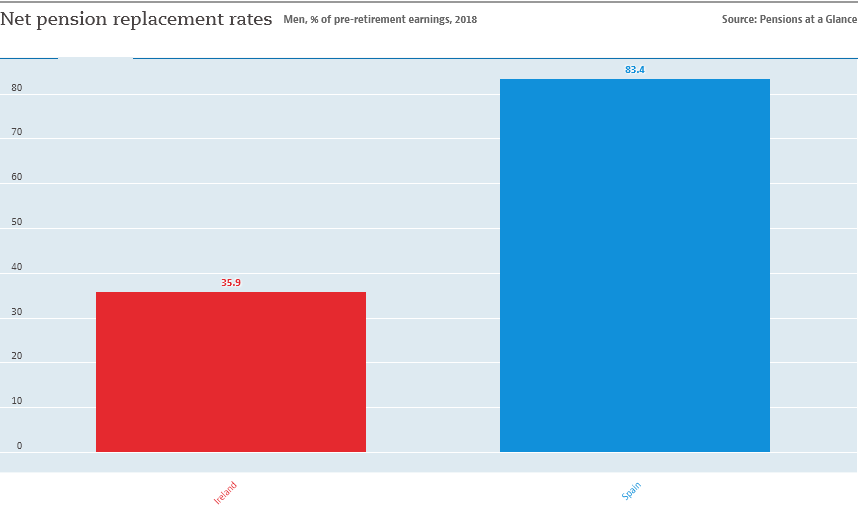Draw attention to some important aspects in this diagram. The smallest bar is red in color. 